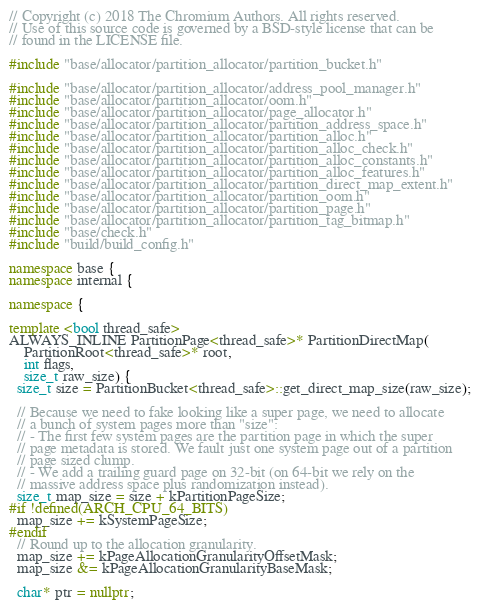Convert code to text. <code><loc_0><loc_0><loc_500><loc_500><_C++_>// Copyright (c) 2018 The Chromium Authors. All rights reserved.
// Use of this source code is governed by a BSD-style license that can be
// found in the LICENSE file.

#include "base/allocator/partition_allocator/partition_bucket.h"

#include "base/allocator/partition_allocator/address_pool_manager.h"
#include "base/allocator/partition_allocator/oom.h"
#include "base/allocator/partition_allocator/page_allocator.h"
#include "base/allocator/partition_allocator/partition_address_space.h"
#include "base/allocator/partition_allocator/partition_alloc.h"
#include "base/allocator/partition_allocator/partition_alloc_check.h"
#include "base/allocator/partition_allocator/partition_alloc_constants.h"
#include "base/allocator/partition_allocator/partition_alloc_features.h"
#include "base/allocator/partition_allocator/partition_direct_map_extent.h"
#include "base/allocator/partition_allocator/partition_oom.h"
#include "base/allocator/partition_allocator/partition_page.h"
#include "base/allocator/partition_allocator/partition_tag_bitmap.h"
#include "base/check.h"
#include "build/build_config.h"

namespace base {
namespace internal {

namespace {

template <bool thread_safe>
ALWAYS_INLINE PartitionPage<thread_safe>* PartitionDirectMap(
    PartitionRoot<thread_safe>* root,
    int flags,
    size_t raw_size) {
  size_t size = PartitionBucket<thread_safe>::get_direct_map_size(raw_size);

  // Because we need to fake looking like a super page, we need to allocate
  // a bunch of system pages more than "size":
  // - The first few system pages are the partition page in which the super
  // page metadata is stored. We fault just one system page out of a partition
  // page sized clump.
  // - We add a trailing guard page on 32-bit (on 64-bit we rely on the
  // massive address space plus randomization instead).
  size_t map_size = size + kPartitionPageSize;
#if !defined(ARCH_CPU_64_BITS)
  map_size += kSystemPageSize;
#endif
  // Round up to the allocation granularity.
  map_size += kPageAllocationGranularityOffsetMask;
  map_size &= kPageAllocationGranularityBaseMask;

  char* ptr = nullptr;</code> 